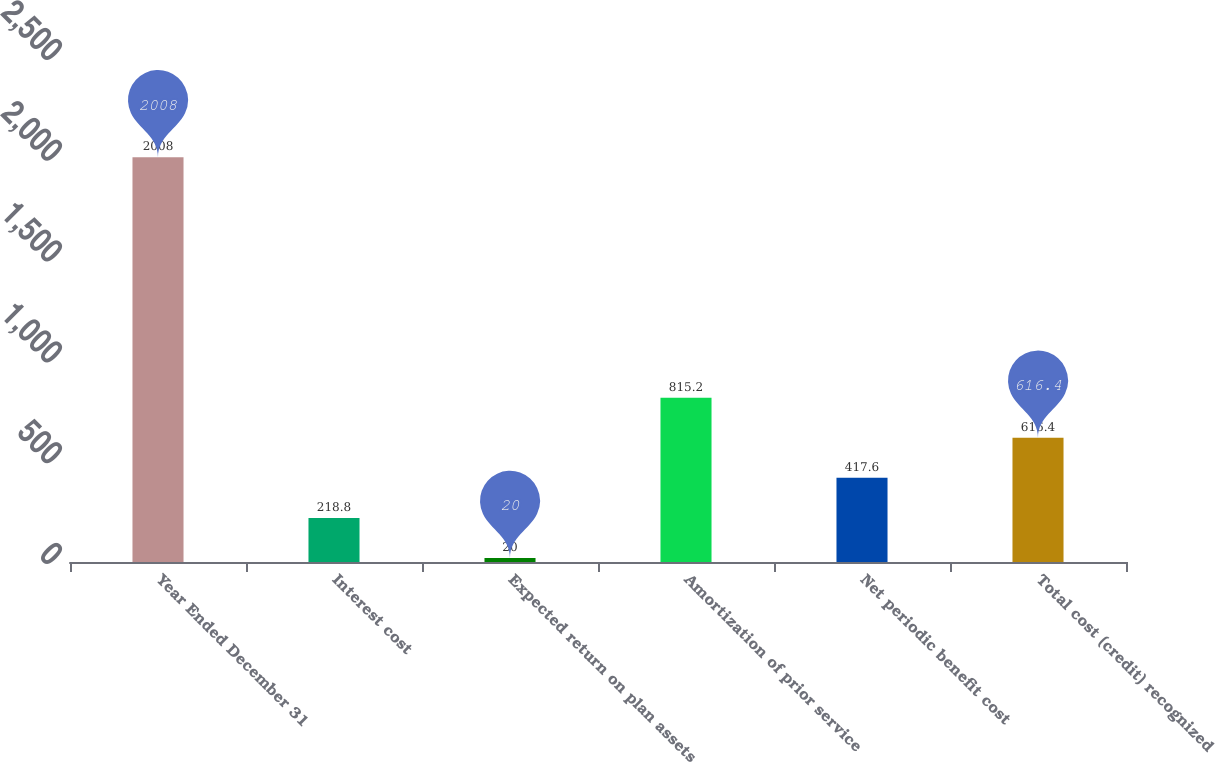Convert chart. <chart><loc_0><loc_0><loc_500><loc_500><bar_chart><fcel>Year Ended December 31<fcel>Interest cost<fcel>Expected return on plan assets<fcel>Amortization of prior service<fcel>Net periodic benefit cost<fcel>Total cost (credit) recognized<nl><fcel>2008<fcel>218.8<fcel>20<fcel>815.2<fcel>417.6<fcel>616.4<nl></chart> 